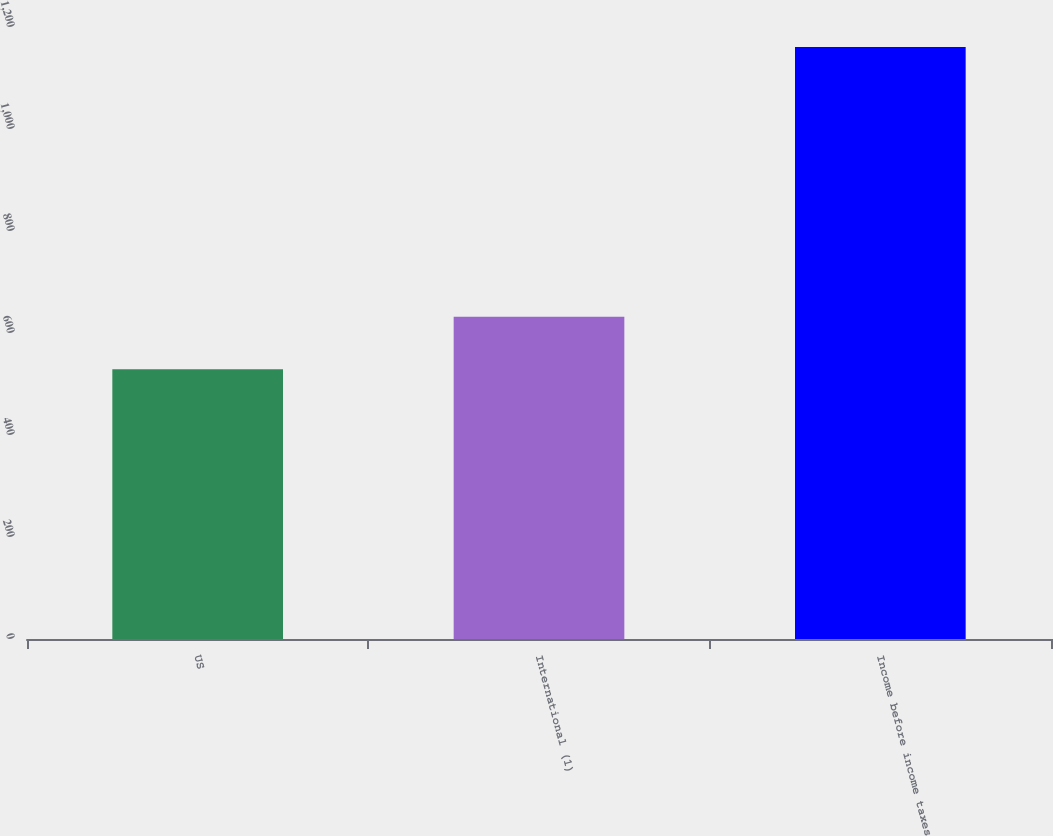Convert chart to OTSL. <chart><loc_0><loc_0><loc_500><loc_500><bar_chart><fcel>US<fcel>International (1)<fcel>Income before income taxes<nl><fcel>529<fcel>632<fcel>1161<nl></chart> 